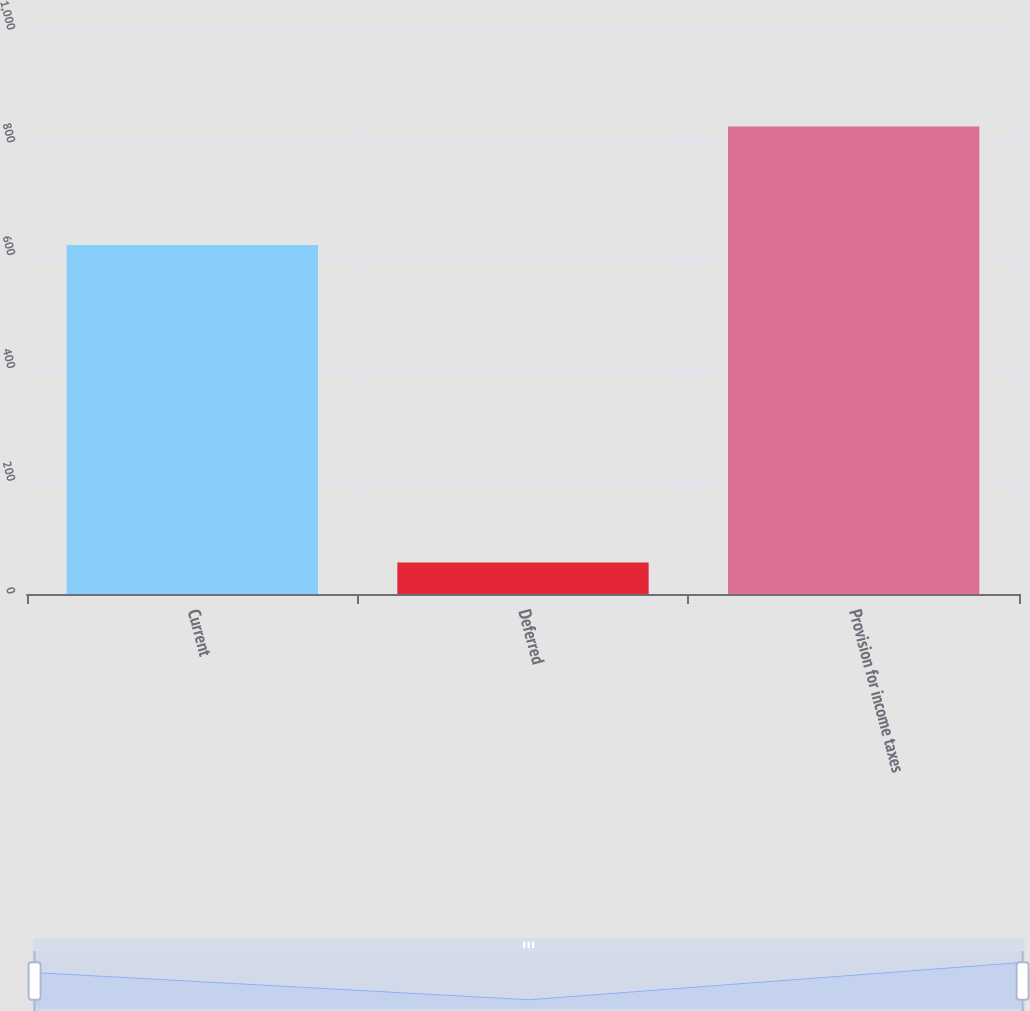Convert chart. <chart><loc_0><loc_0><loc_500><loc_500><bar_chart><fcel>Current<fcel>Deferred<fcel>Provision for income taxes<nl><fcel>619<fcel>56<fcel>829<nl></chart> 